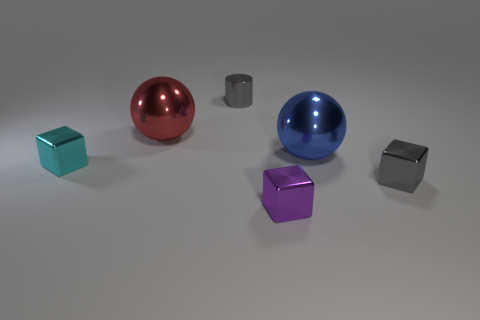Add 2 red shiny things. How many objects exist? 8 Subtract all spheres. How many objects are left? 4 Add 1 big shiny spheres. How many big shiny spheres exist? 3 Subtract 0 cyan cylinders. How many objects are left? 6 Subtract all red balls. Subtract all purple blocks. How many objects are left? 4 Add 1 small purple things. How many small purple things are left? 2 